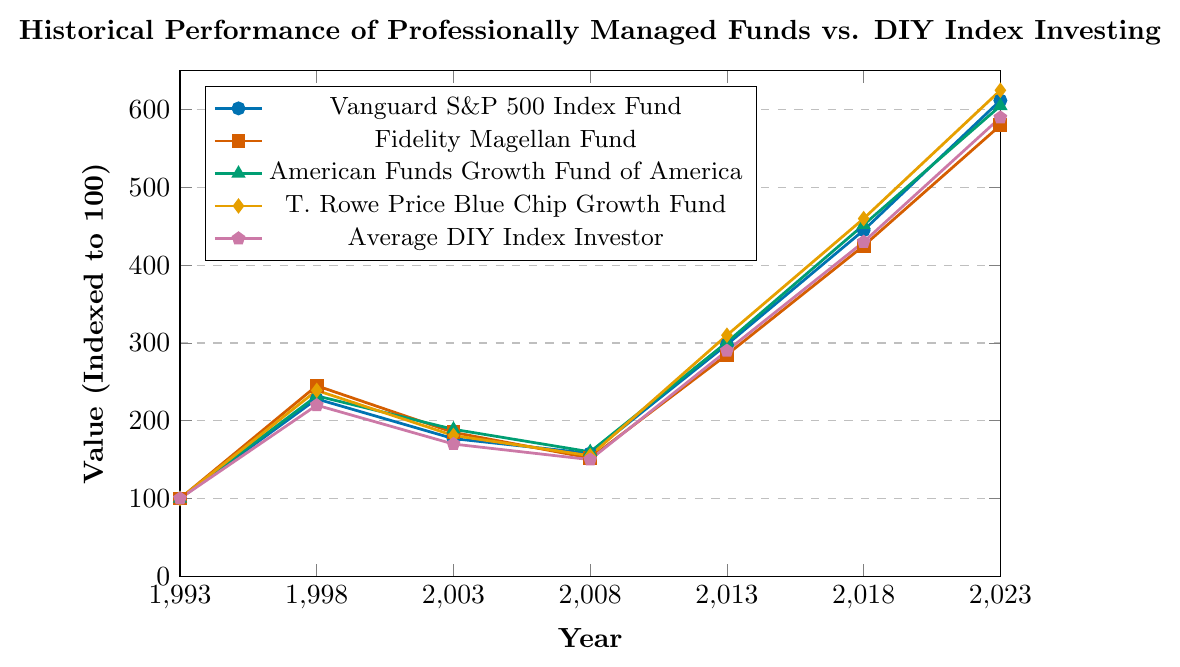What is the trend of the Vanguard S&P 500 Index Fund over the 30-year period? The Vanguard S&P 500 Index Fund starts at 100 in 1993 and steadily increases to 612 by 2023, showing a general upwards trend with some dips along the way.
Answer: Upwards trend How does the performance of the Fidelity Magellan Fund compare to the T. Rowe Price Blue Chip Growth Fund in 2013? In 2013, the Fidelity Magellan Fund is at 285, while the T. Rowe Price Blue Chip Growth Fund is at 310, meaning the latter performed better.
Answer: T. Rowe Price Blue Chip Growth Fund performed better What is the difference in value between the Average DIY Index Investor and the American Funds Growth Fund of America in 2018? In 2018, the Average DIY Index Investor is at 430, and the American Funds Growth Fund of America is at 452. The difference is 452 - 430 = 22.
Answer: 22 Which fund had the highest value in 2023 and what is that value? The T. Rowe Price Blue Chip Growth Fund had the highest value in 2023 with a value of 625.
Answer: T. Rowe Price Blue Chip Growth Fund, 625 Did any of the funds show a decrease in value from 1998 to 2003? From 1998 to 2003, the values are: Vanguard S&P 500 Index Fund (228 to 177), Fidelity Magellan Fund (245 to 185), American Funds Growth Fund of America (232 to 189), T. Rowe Price Blue Chip Growth Fund (239 to 181), and Average DIY Index Investor (220 to 170). All funds show a decrease.
Answer: Yes Between which two consecutive periods did the T. Rowe Price Blue Chip Growth Fund experience the smallest increase in value? T. Rowe Price Blue Chip Growth Fund values: 1993 (100), 1998 (239), 2003 (181), 2008 (155), 2013 (310), 2018 (460), 2023 (625). The smallest increase is from 1998 to 2003 where the value decreased from 239 to 181.
Answer: 1998 to 2003 What is the average value of all funds in 2008? In 2008, the values are: Vanguard S&P 500 Index Fund (158), Fidelity Magellan Fund (152), American Funds Growth Fund of America (160), T. Rowe Price Blue Chip Growth Fund (155), and Average DIY Index Investor (150). The average value is (158 + 152 + 160 + 155 + 150) / 5 = 155.
Answer: 155 Which fund showed the greatest growth from 2013 to 2018? T. Rowe Price Blue Chip Growth Fund (310 to 460), growth = 150; American Funds Growth Fund of America (301 to 452), growth = 151; Fidelity Magellan Fund (285 to 425), growth = 140; Vanguard S&P 500 Index Fund (298 to 445), growth = 147; Average DIY Index Investor (290 to 430), growth = 140. The American Funds Growth Fund of America showed the greatest growth of 151.
Answer: American Funds Growth Fund of America What was the overall pattern for all funds during the 2008 economic crisis? During the 2008 economic crisis, all funds showed a decrease in value: Vanguard S&P 500 Index Fund (177 to 158), Fidelity Magellan Fund (185 to 152), American Funds Growth Fund of America (189 to 160), T. Rowe Price Blue Chip Growth Fund (181 to 155), and Average DIY Index Investor (170 to 150).
Answer: Decrease How much did the T. Rowe Price Blue Chip Growth Fund grow from 1993 to 2023? T. Rowe Price Blue Chip Growth Fund values: 1993 (100) and 2023 (625). The growth is 625 - 100 = 525.
Answer: 525 